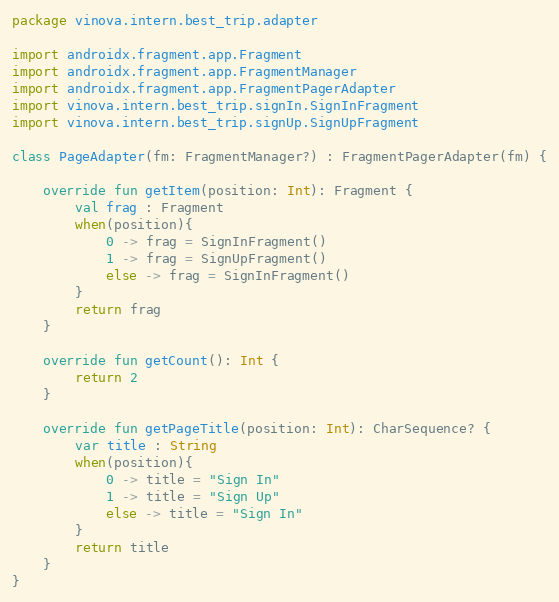Convert code to text. <code><loc_0><loc_0><loc_500><loc_500><_Kotlin_>package vinova.intern.best_trip.adapter

import androidx.fragment.app.Fragment
import androidx.fragment.app.FragmentManager
import androidx.fragment.app.FragmentPagerAdapter
import vinova.intern.best_trip.signIn.SignInFragment
import vinova.intern.best_trip.signUp.SignUpFragment

class PageAdapter(fm: FragmentManager?) : FragmentPagerAdapter(fm) {

	override fun getItem(position: Int): Fragment {
		val frag : Fragment
		when(position){
			0 -> frag = SignInFragment()
			1 -> frag = SignUpFragment()
			else -> frag = SignInFragment()
		}
		return frag
	}

	override fun getCount(): Int {
		return 2
	}

	override fun getPageTitle(position: Int): CharSequence? {
		var title : String
		when(position){
			0 -> title = "Sign In"
			1 -> title = "Sign Up"
			else -> title = "Sign In"
		}
		return title
	}
}</code> 